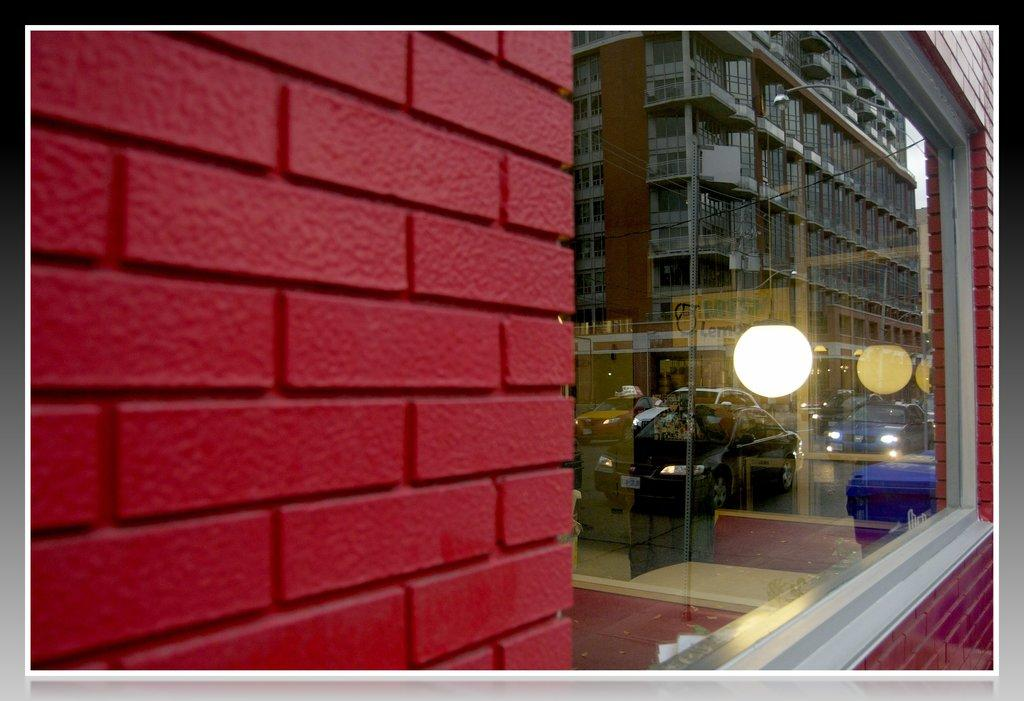What is present on the wall in the image? There is a glass window on the wall in the image. What can be seen through the window? Vehicles, at least one building, and poles are visible through the window. How many elements can be seen through the window? Three elements can be seen through the window: vehicles, a building, and poles. What type of bird is sitting on the sheep in the image? There is no bird or sheep present in the image; it only features a wall with a glass window and the view through the window. 